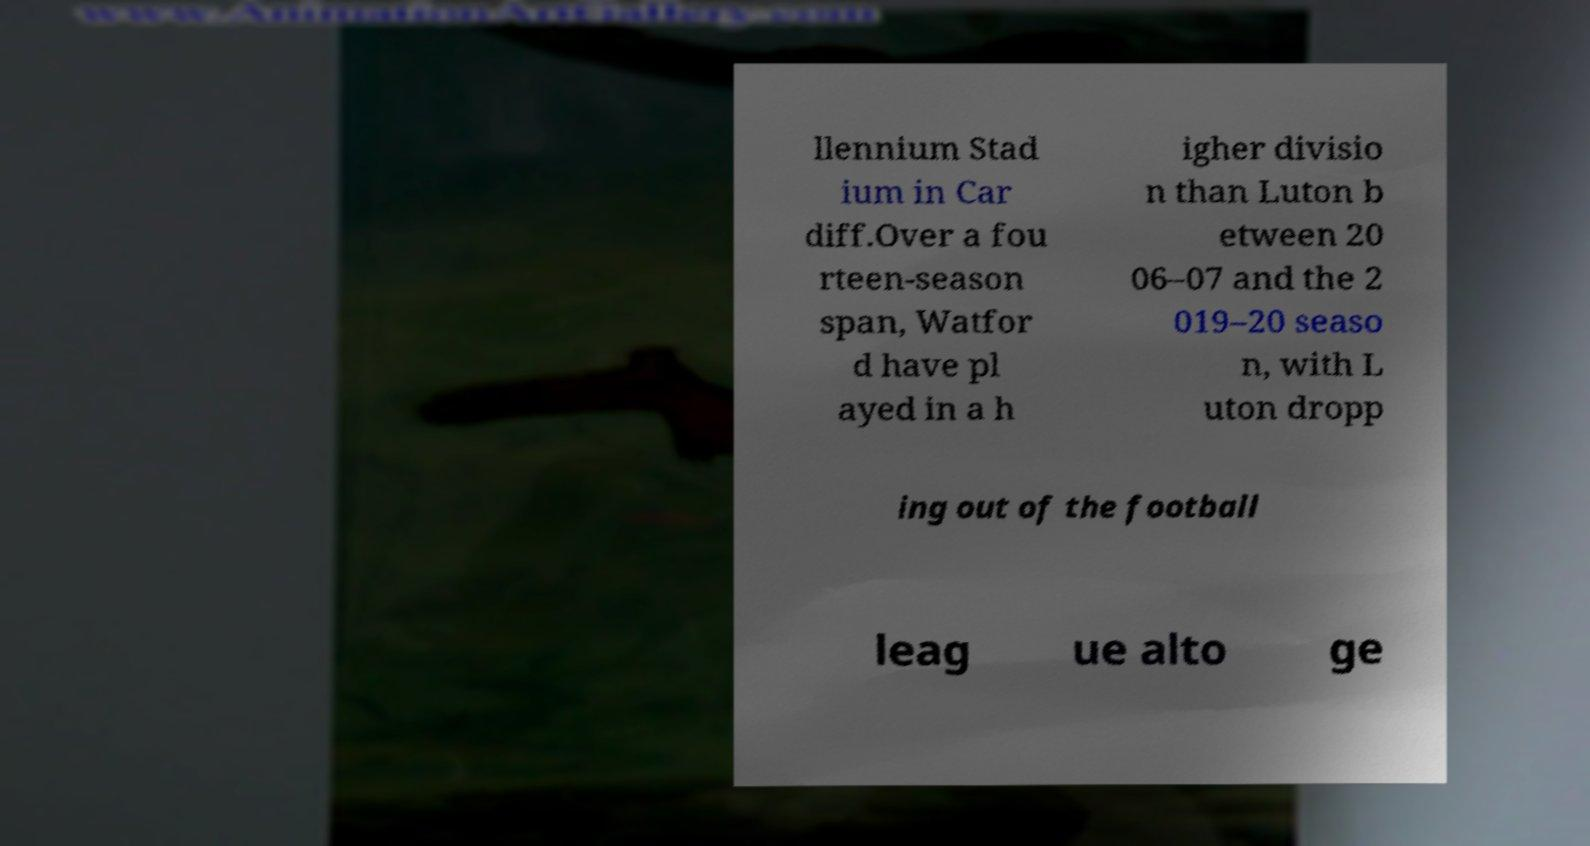There's text embedded in this image that I need extracted. Can you transcribe it verbatim? llennium Stad ium in Car diff.Over a fou rteen-season span, Watfor d have pl ayed in a h igher divisio n than Luton b etween 20 06–07 and the 2 019–20 seaso n, with L uton dropp ing out of the football leag ue alto ge 